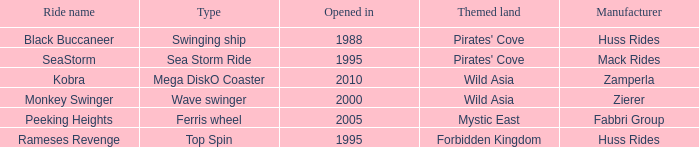What type of ride is Rameses Revenge? Top Spin. 